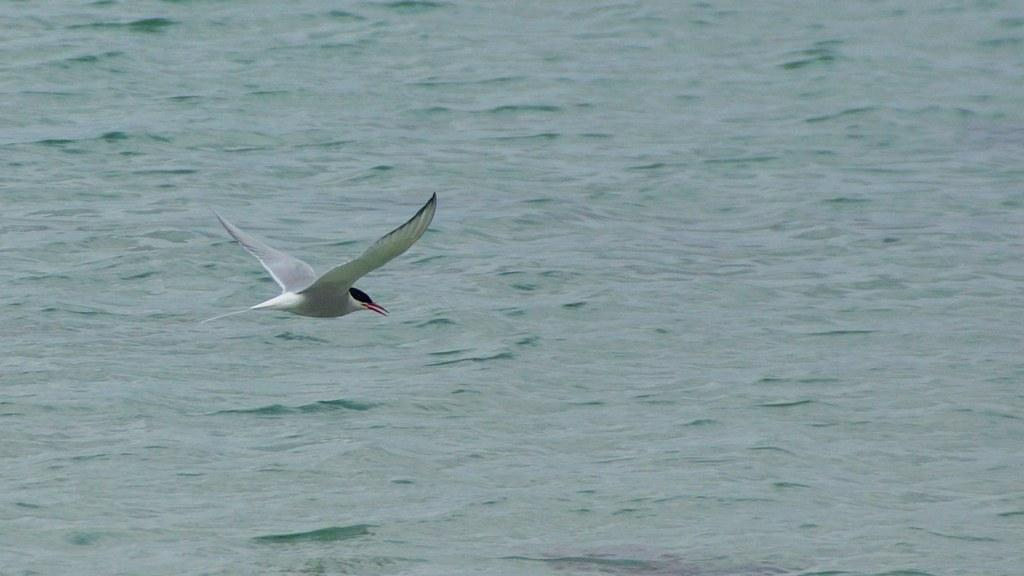What is the main subject of the image? There is a bird flying in the air in the image. What can be seen in the background of the image? There is a sea visible in the background of the image. What type of plantation can be seen in the image? There is no plantation present in the image; it features a bird flying in the air and a sea in the background. 